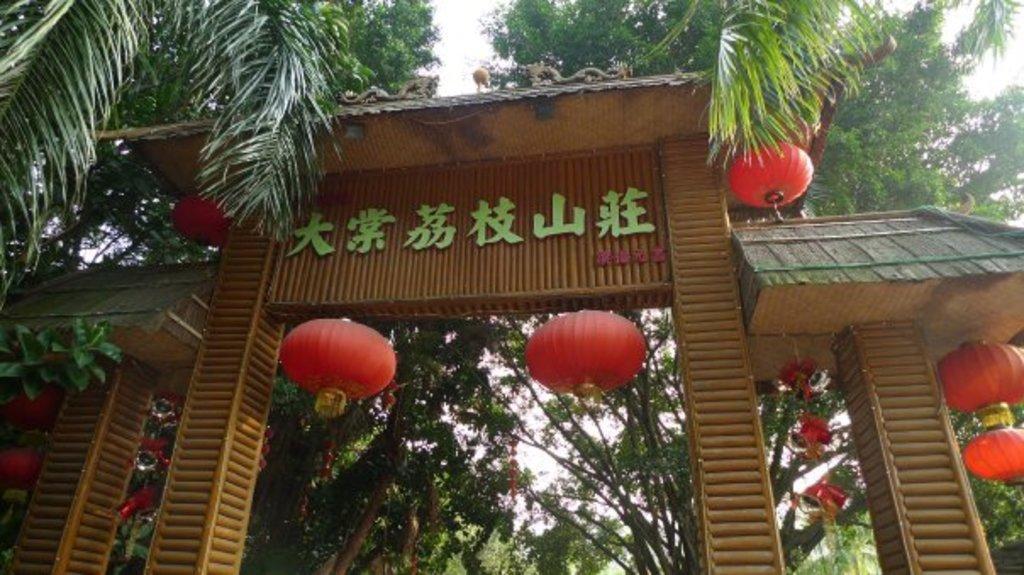Can you describe this image briefly? In this image we can see an arch with some lights. On the backside we can see a group of trees and the sky. 